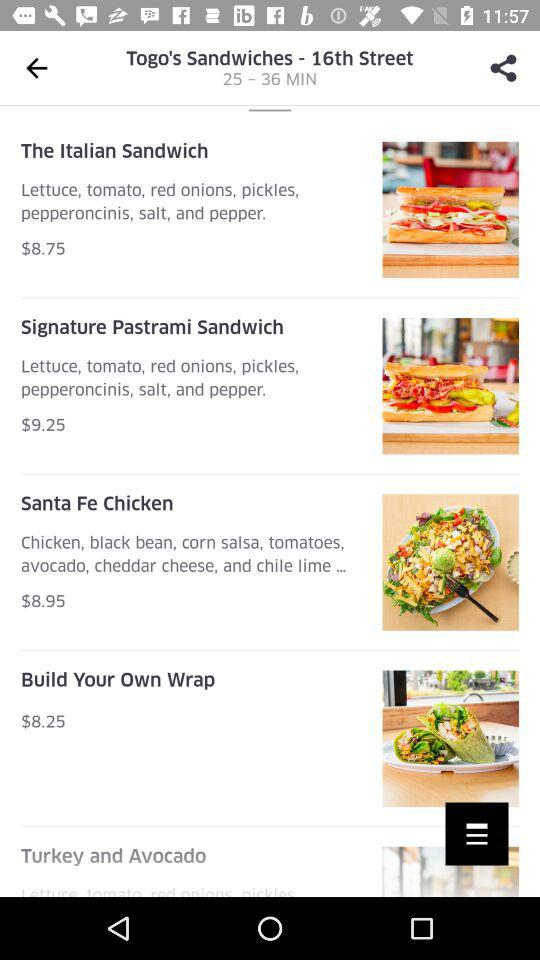What types of sandwiches do we have? The types of sandwiches are "The Italian Sandwich" and "Signature Pastrami Sandwich". 